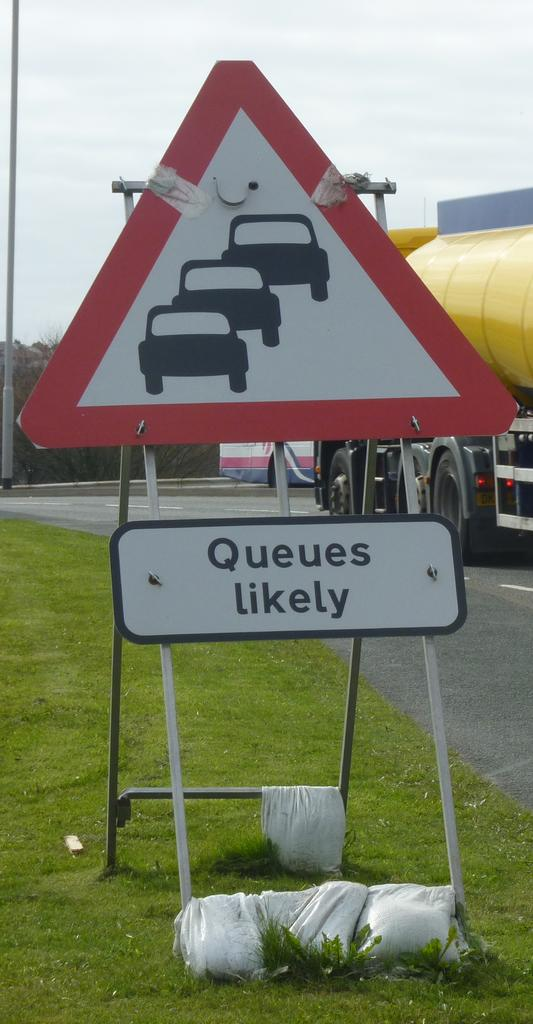Provide a one-sentence caption for the provided image. a yield sign has queues likely sits by the road. 